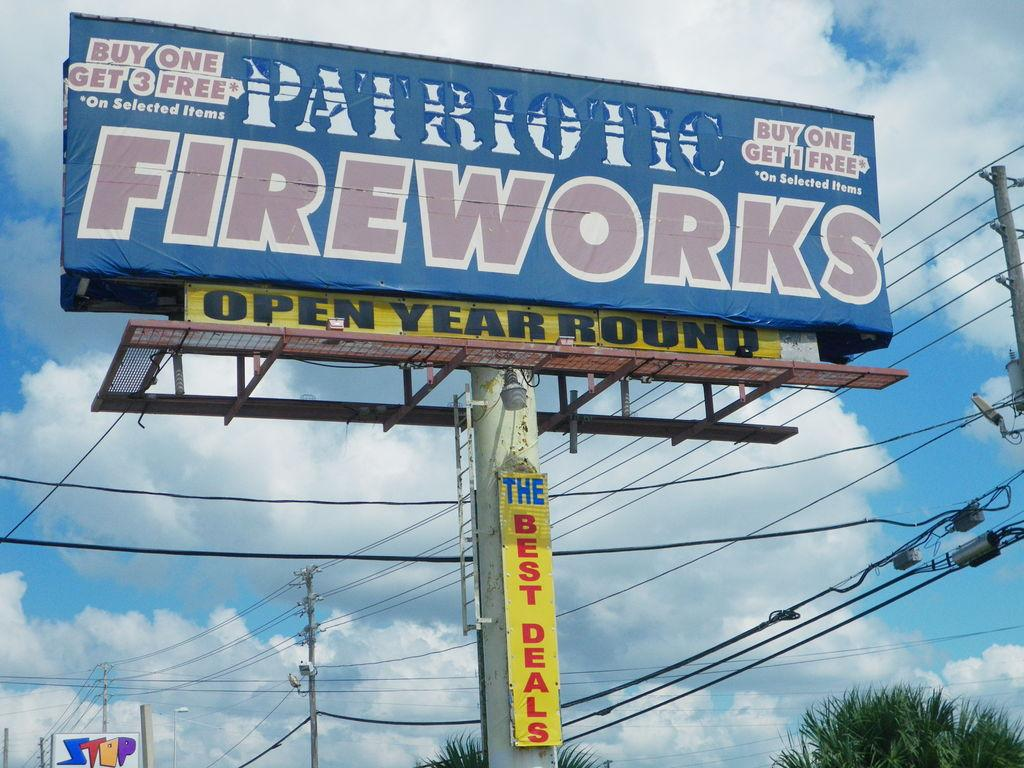<image>
Describe the image concisely. Big sign outside with Patriotic Fireworks wrote on it 